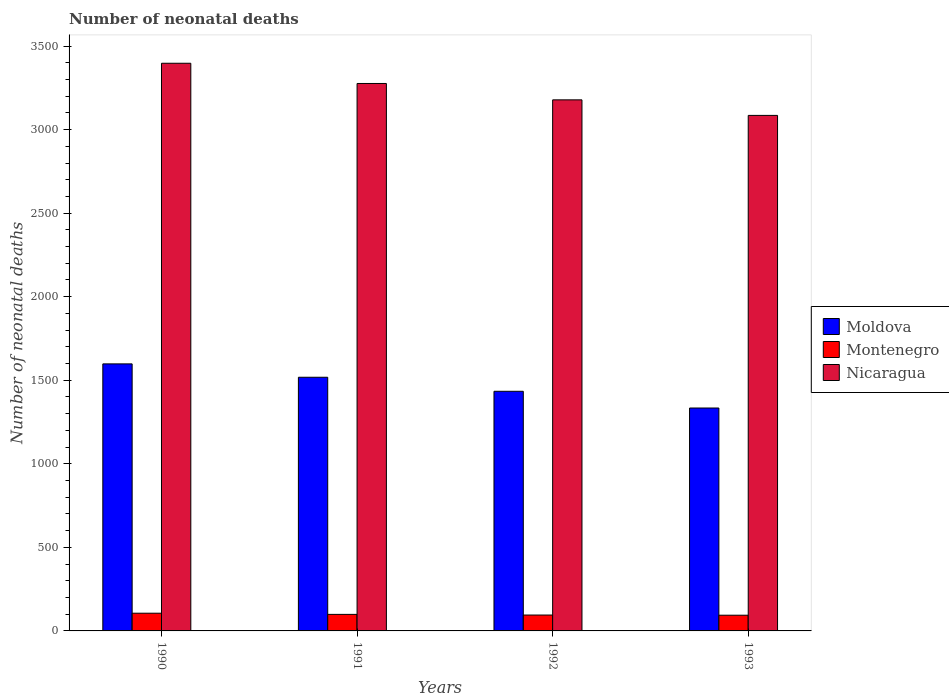How many different coloured bars are there?
Your response must be concise. 3. Are the number of bars on each tick of the X-axis equal?
Give a very brief answer. Yes. How many bars are there on the 1st tick from the right?
Offer a terse response. 3. What is the label of the 1st group of bars from the left?
Make the answer very short. 1990. In how many cases, is the number of bars for a given year not equal to the number of legend labels?
Provide a short and direct response. 0. What is the number of neonatal deaths in in Montenegro in 1992?
Give a very brief answer. 95. Across all years, what is the maximum number of neonatal deaths in in Nicaragua?
Offer a very short reply. 3397. Across all years, what is the minimum number of neonatal deaths in in Nicaragua?
Offer a terse response. 3085. What is the total number of neonatal deaths in in Nicaragua in the graph?
Offer a terse response. 1.29e+04. What is the difference between the number of neonatal deaths in in Moldova in 1990 and that in 1991?
Give a very brief answer. 80. What is the difference between the number of neonatal deaths in in Montenegro in 1992 and the number of neonatal deaths in in Moldova in 1990?
Make the answer very short. -1503. What is the average number of neonatal deaths in in Montenegro per year?
Your response must be concise. 98.5. In the year 1991, what is the difference between the number of neonatal deaths in in Montenegro and number of neonatal deaths in in Nicaragua?
Give a very brief answer. -3177. In how many years, is the number of neonatal deaths in in Moldova greater than 1100?
Your response must be concise. 4. What is the ratio of the number of neonatal deaths in in Nicaragua in 1990 to that in 1993?
Your answer should be very brief. 1.1. Is the number of neonatal deaths in in Nicaragua in 1990 less than that in 1993?
Your answer should be compact. No. Is the difference between the number of neonatal deaths in in Montenegro in 1990 and 1993 greater than the difference between the number of neonatal deaths in in Nicaragua in 1990 and 1993?
Your answer should be compact. No. What is the difference between the highest and the lowest number of neonatal deaths in in Montenegro?
Offer a very short reply. 12. What does the 3rd bar from the left in 1992 represents?
Keep it short and to the point. Nicaragua. What does the 3rd bar from the right in 1992 represents?
Provide a succinct answer. Moldova. Is it the case that in every year, the sum of the number of neonatal deaths in in Montenegro and number of neonatal deaths in in Moldova is greater than the number of neonatal deaths in in Nicaragua?
Offer a terse response. No. What is the difference between two consecutive major ticks on the Y-axis?
Ensure brevity in your answer.  500. Are the values on the major ticks of Y-axis written in scientific E-notation?
Offer a terse response. No. Does the graph contain any zero values?
Your response must be concise. No. Does the graph contain grids?
Provide a short and direct response. No. Where does the legend appear in the graph?
Your answer should be compact. Center right. How many legend labels are there?
Your answer should be compact. 3. What is the title of the graph?
Your answer should be compact. Number of neonatal deaths. Does "Upper middle income" appear as one of the legend labels in the graph?
Ensure brevity in your answer.  No. What is the label or title of the Y-axis?
Offer a very short reply. Number of neonatal deaths. What is the Number of neonatal deaths of Moldova in 1990?
Provide a succinct answer. 1598. What is the Number of neonatal deaths in Montenegro in 1990?
Your response must be concise. 106. What is the Number of neonatal deaths of Nicaragua in 1990?
Provide a succinct answer. 3397. What is the Number of neonatal deaths of Moldova in 1991?
Your answer should be very brief. 1518. What is the Number of neonatal deaths in Montenegro in 1991?
Offer a terse response. 99. What is the Number of neonatal deaths in Nicaragua in 1991?
Keep it short and to the point. 3276. What is the Number of neonatal deaths in Moldova in 1992?
Your answer should be very brief. 1434. What is the Number of neonatal deaths of Montenegro in 1992?
Your answer should be very brief. 95. What is the Number of neonatal deaths in Nicaragua in 1992?
Offer a terse response. 3178. What is the Number of neonatal deaths in Moldova in 1993?
Give a very brief answer. 1334. What is the Number of neonatal deaths of Montenegro in 1993?
Your answer should be very brief. 94. What is the Number of neonatal deaths of Nicaragua in 1993?
Your answer should be very brief. 3085. Across all years, what is the maximum Number of neonatal deaths of Moldova?
Provide a succinct answer. 1598. Across all years, what is the maximum Number of neonatal deaths in Montenegro?
Your response must be concise. 106. Across all years, what is the maximum Number of neonatal deaths in Nicaragua?
Offer a terse response. 3397. Across all years, what is the minimum Number of neonatal deaths in Moldova?
Ensure brevity in your answer.  1334. Across all years, what is the minimum Number of neonatal deaths of Montenegro?
Your answer should be compact. 94. Across all years, what is the minimum Number of neonatal deaths of Nicaragua?
Your answer should be very brief. 3085. What is the total Number of neonatal deaths in Moldova in the graph?
Your answer should be compact. 5884. What is the total Number of neonatal deaths in Montenegro in the graph?
Offer a terse response. 394. What is the total Number of neonatal deaths of Nicaragua in the graph?
Give a very brief answer. 1.29e+04. What is the difference between the Number of neonatal deaths in Moldova in 1990 and that in 1991?
Ensure brevity in your answer.  80. What is the difference between the Number of neonatal deaths in Montenegro in 1990 and that in 1991?
Your answer should be very brief. 7. What is the difference between the Number of neonatal deaths in Nicaragua in 1990 and that in 1991?
Your response must be concise. 121. What is the difference between the Number of neonatal deaths in Moldova in 1990 and that in 1992?
Provide a short and direct response. 164. What is the difference between the Number of neonatal deaths of Montenegro in 1990 and that in 1992?
Keep it short and to the point. 11. What is the difference between the Number of neonatal deaths in Nicaragua in 1990 and that in 1992?
Your answer should be very brief. 219. What is the difference between the Number of neonatal deaths in Moldova in 1990 and that in 1993?
Provide a succinct answer. 264. What is the difference between the Number of neonatal deaths in Montenegro in 1990 and that in 1993?
Keep it short and to the point. 12. What is the difference between the Number of neonatal deaths in Nicaragua in 1990 and that in 1993?
Ensure brevity in your answer.  312. What is the difference between the Number of neonatal deaths of Moldova in 1991 and that in 1992?
Ensure brevity in your answer.  84. What is the difference between the Number of neonatal deaths in Moldova in 1991 and that in 1993?
Ensure brevity in your answer.  184. What is the difference between the Number of neonatal deaths of Montenegro in 1991 and that in 1993?
Provide a succinct answer. 5. What is the difference between the Number of neonatal deaths in Nicaragua in 1991 and that in 1993?
Offer a terse response. 191. What is the difference between the Number of neonatal deaths in Moldova in 1992 and that in 1993?
Your response must be concise. 100. What is the difference between the Number of neonatal deaths in Montenegro in 1992 and that in 1993?
Your answer should be very brief. 1. What is the difference between the Number of neonatal deaths in Nicaragua in 1992 and that in 1993?
Give a very brief answer. 93. What is the difference between the Number of neonatal deaths of Moldova in 1990 and the Number of neonatal deaths of Montenegro in 1991?
Your answer should be very brief. 1499. What is the difference between the Number of neonatal deaths of Moldova in 1990 and the Number of neonatal deaths of Nicaragua in 1991?
Your answer should be very brief. -1678. What is the difference between the Number of neonatal deaths in Montenegro in 1990 and the Number of neonatal deaths in Nicaragua in 1991?
Your response must be concise. -3170. What is the difference between the Number of neonatal deaths in Moldova in 1990 and the Number of neonatal deaths in Montenegro in 1992?
Ensure brevity in your answer.  1503. What is the difference between the Number of neonatal deaths in Moldova in 1990 and the Number of neonatal deaths in Nicaragua in 1992?
Keep it short and to the point. -1580. What is the difference between the Number of neonatal deaths in Montenegro in 1990 and the Number of neonatal deaths in Nicaragua in 1992?
Offer a very short reply. -3072. What is the difference between the Number of neonatal deaths of Moldova in 1990 and the Number of neonatal deaths of Montenegro in 1993?
Your answer should be very brief. 1504. What is the difference between the Number of neonatal deaths in Moldova in 1990 and the Number of neonatal deaths in Nicaragua in 1993?
Make the answer very short. -1487. What is the difference between the Number of neonatal deaths in Montenegro in 1990 and the Number of neonatal deaths in Nicaragua in 1993?
Give a very brief answer. -2979. What is the difference between the Number of neonatal deaths of Moldova in 1991 and the Number of neonatal deaths of Montenegro in 1992?
Your answer should be compact. 1423. What is the difference between the Number of neonatal deaths of Moldova in 1991 and the Number of neonatal deaths of Nicaragua in 1992?
Provide a succinct answer. -1660. What is the difference between the Number of neonatal deaths of Montenegro in 1991 and the Number of neonatal deaths of Nicaragua in 1992?
Keep it short and to the point. -3079. What is the difference between the Number of neonatal deaths of Moldova in 1991 and the Number of neonatal deaths of Montenegro in 1993?
Your answer should be compact. 1424. What is the difference between the Number of neonatal deaths in Moldova in 1991 and the Number of neonatal deaths in Nicaragua in 1993?
Offer a very short reply. -1567. What is the difference between the Number of neonatal deaths in Montenegro in 1991 and the Number of neonatal deaths in Nicaragua in 1993?
Ensure brevity in your answer.  -2986. What is the difference between the Number of neonatal deaths in Moldova in 1992 and the Number of neonatal deaths in Montenegro in 1993?
Offer a terse response. 1340. What is the difference between the Number of neonatal deaths of Moldova in 1992 and the Number of neonatal deaths of Nicaragua in 1993?
Give a very brief answer. -1651. What is the difference between the Number of neonatal deaths in Montenegro in 1992 and the Number of neonatal deaths in Nicaragua in 1993?
Provide a succinct answer. -2990. What is the average Number of neonatal deaths in Moldova per year?
Offer a terse response. 1471. What is the average Number of neonatal deaths of Montenegro per year?
Your response must be concise. 98.5. What is the average Number of neonatal deaths of Nicaragua per year?
Keep it short and to the point. 3234. In the year 1990, what is the difference between the Number of neonatal deaths of Moldova and Number of neonatal deaths of Montenegro?
Your answer should be very brief. 1492. In the year 1990, what is the difference between the Number of neonatal deaths in Moldova and Number of neonatal deaths in Nicaragua?
Offer a very short reply. -1799. In the year 1990, what is the difference between the Number of neonatal deaths in Montenegro and Number of neonatal deaths in Nicaragua?
Provide a short and direct response. -3291. In the year 1991, what is the difference between the Number of neonatal deaths in Moldova and Number of neonatal deaths in Montenegro?
Provide a short and direct response. 1419. In the year 1991, what is the difference between the Number of neonatal deaths of Moldova and Number of neonatal deaths of Nicaragua?
Make the answer very short. -1758. In the year 1991, what is the difference between the Number of neonatal deaths of Montenegro and Number of neonatal deaths of Nicaragua?
Keep it short and to the point. -3177. In the year 1992, what is the difference between the Number of neonatal deaths of Moldova and Number of neonatal deaths of Montenegro?
Give a very brief answer. 1339. In the year 1992, what is the difference between the Number of neonatal deaths of Moldova and Number of neonatal deaths of Nicaragua?
Give a very brief answer. -1744. In the year 1992, what is the difference between the Number of neonatal deaths of Montenegro and Number of neonatal deaths of Nicaragua?
Your response must be concise. -3083. In the year 1993, what is the difference between the Number of neonatal deaths of Moldova and Number of neonatal deaths of Montenegro?
Your answer should be compact. 1240. In the year 1993, what is the difference between the Number of neonatal deaths of Moldova and Number of neonatal deaths of Nicaragua?
Ensure brevity in your answer.  -1751. In the year 1993, what is the difference between the Number of neonatal deaths in Montenegro and Number of neonatal deaths in Nicaragua?
Ensure brevity in your answer.  -2991. What is the ratio of the Number of neonatal deaths in Moldova in 1990 to that in 1991?
Ensure brevity in your answer.  1.05. What is the ratio of the Number of neonatal deaths of Montenegro in 1990 to that in 1991?
Keep it short and to the point. 1.07. What is the ratio of the Number of neonatal deaths in Nicaragua in 1990 to that in 1991?
Your response must be concise. 1.04. What is the ratio of the Number of neonatal deaths of Moldova in 1990 to that in 1992?
Your answer should be compact. 1.11. What is the ratio of the Number of neonatal deaths in Montenegro in 1990 to that in 1992?
Give a very brief answer. 1.12. What is the ratio of the Number of neonatal deaths in Nicaragua in 1990 to that in 1992?
Your response must be concise. 1.07. What is the ratio of the Number of neonatal deaths of Moldova in 1990 to that in 1993?
Your answer should be very brief. 1.2. What is the ratio of the Number of neonatal deaths of Montenegro in 1990 to that in 1993?
Provide a short and direct response. 1.13. What is the ratio of the Number of neonatal deaths of Nicaragua in 1990 to that in 1993?
Ensure brevity in your answer.  1.1. What is the ratio of the Number of neonatal deaths in Moldova in 1991 to that in 1992?
Give a very brief answer. 1.06. What is the ratio of the Number of neonatal deaths of Montenegro in 1991 to that in 1992?
Make the answer very short. 1.04. What is the ratio of the Number of neonatal deaths in Nicaragua in 1991 to that in 1992?
Your answer should be compact. 1.03. What is the ratio of the Number of neonatal deaths of Moldova in 1991 to that in 1993?
Make the answer very short. 1.14. What is the ratio of the Number of neonatal deaths of Montenegro in 1991 to that in 1993?
Keep it short and to the point. 1.05. What is the ratio of the Number of neonatal deaths of Nicaragua in 1991 to that in 1993?
Keep it short and to the point. 1.06. What is the ratio of the Number of neonatal deaths of Moldova in 1992 to that in 1993?
Make the answer very short. 1.07. What is the ratio of the Number of neonatal deaths in Montenegro in 1992 to that in 1993?
Your answer should be compact. 1.01. What is the ratio of the Number of neonatal deaths of Nicaragua in 1992 to that in 1993?
Your answer should be compact. 1.03. What is the difference between the highest and the second highest Number of neonatal deaths of Moldova?
Offer a very short reply. 80. What is the difference between the highest and the second highest Number of neonatal deaths of Montenegro?
Make the answer very short. 7. What is the difference between the highest and the second highest Number of neonatal deaths in Nicaragua?
Make the answer very short. 121. What is the difference between the highest and the lowest Number of neonatal deaths in Moldova?
Provide a succinct answer. 264. What is the difference between the highest and the lowest Number of neonatal deaths in Nicaragua?
Your answer should be compact. 312. 